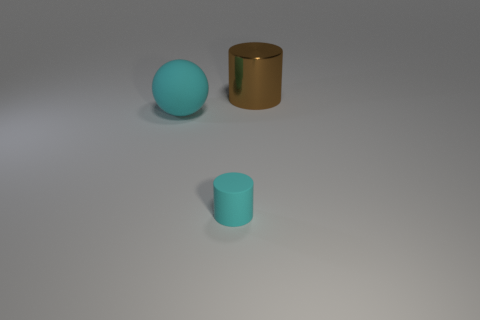Does the large object that is behind the big cyan matte object have the same color as the matte ball?
Ensure brevity in your answer.  No. The cyan object on the right side of the large object in front of the brown shiny cylinder is what shape?
Your answer should be compact. Cylinder. Are there any gray metal balls that have the same size as the shiny cylinder?
Provide a succinct answer. No. Is the number of cyan objects less than the number of gray cubes?
Provide a succinct answer. No. There is a thing that is on the left side of the cylinder to the left of the cylinder behind the small cyan cylinder; what shape is it?
Offer a terse response. Sphere. How many things are either cylinders that are to the right of the cyan rubber cylinder or big objects in front of the brown thing?
Ensure brevity in your answer.  2. There is a big rubber ball; are there any metallic cylinders on the left side of it?
Provide a succinct answer. No. What number of objects are either cylinders that are on the left side of the shiny cylinder or big brown metal blocks?
Keep it short and to the point. 1. What number of green objects are either tiny matte cylinders or big shiny things?
Keep it short and to the point. 0. What number of other objects are there of the same color as the large matte thing?
Offer a very short reply. 1. 